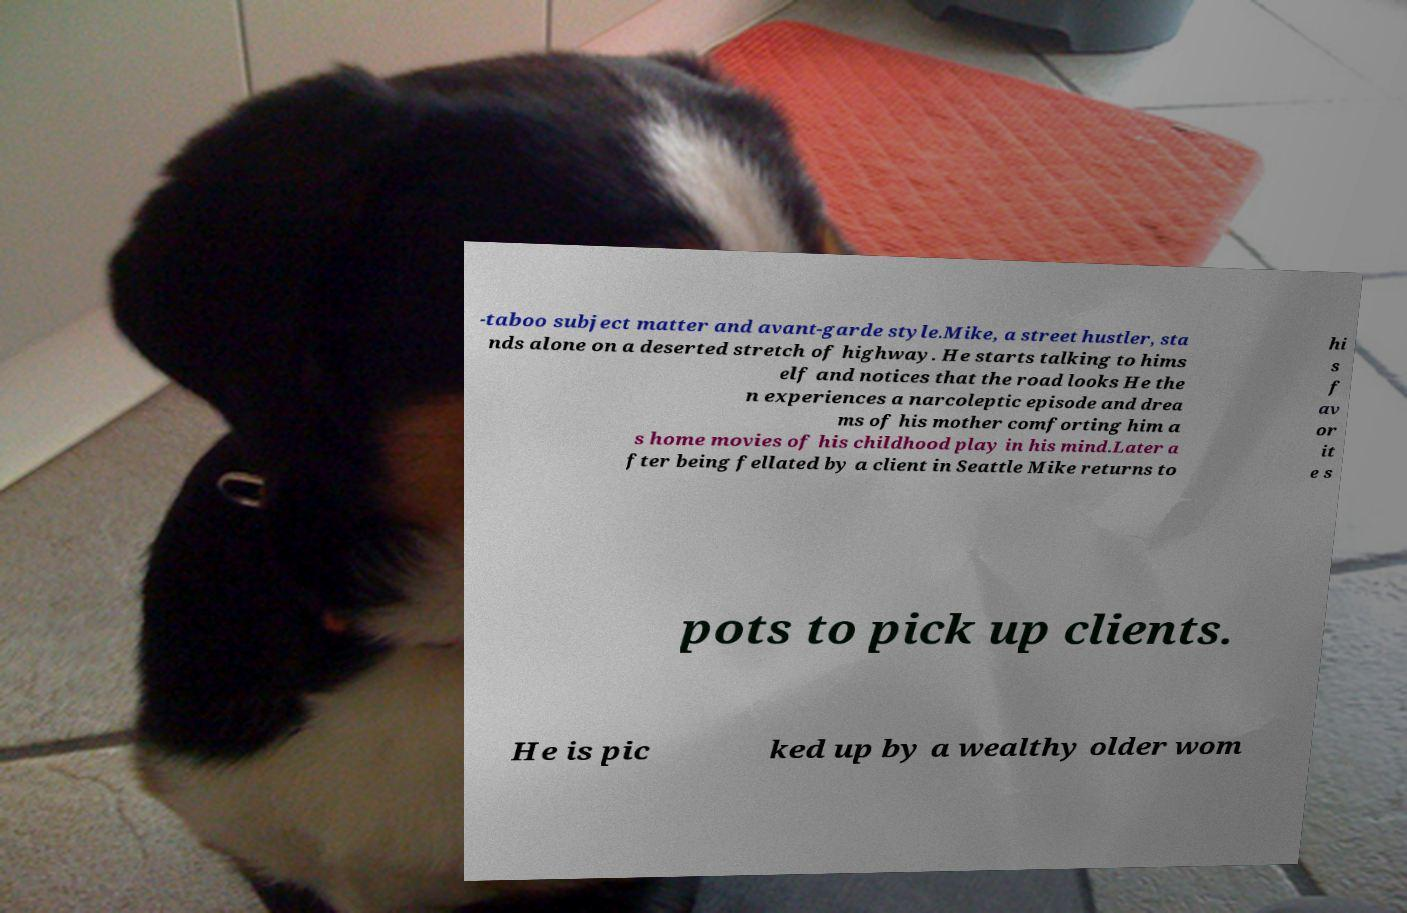What messages or text are displayed in this image? I need them in a readable, typed format. -taboo subject matter and avant-garde style.Mike, a street hustler, sta nds alone on a deserted stretch of highway. He starts talking to hims elf and notices that the road looks He the n experiences a narcoleptic episode and drea ms of his mother comforting him a s home movies of his childhood play in his mind.Later a fter being fellated by a client in Seattle Mike returns to hi s f av or it e s pots to pick up clients. He is pic ked up by a wealthy older wom 